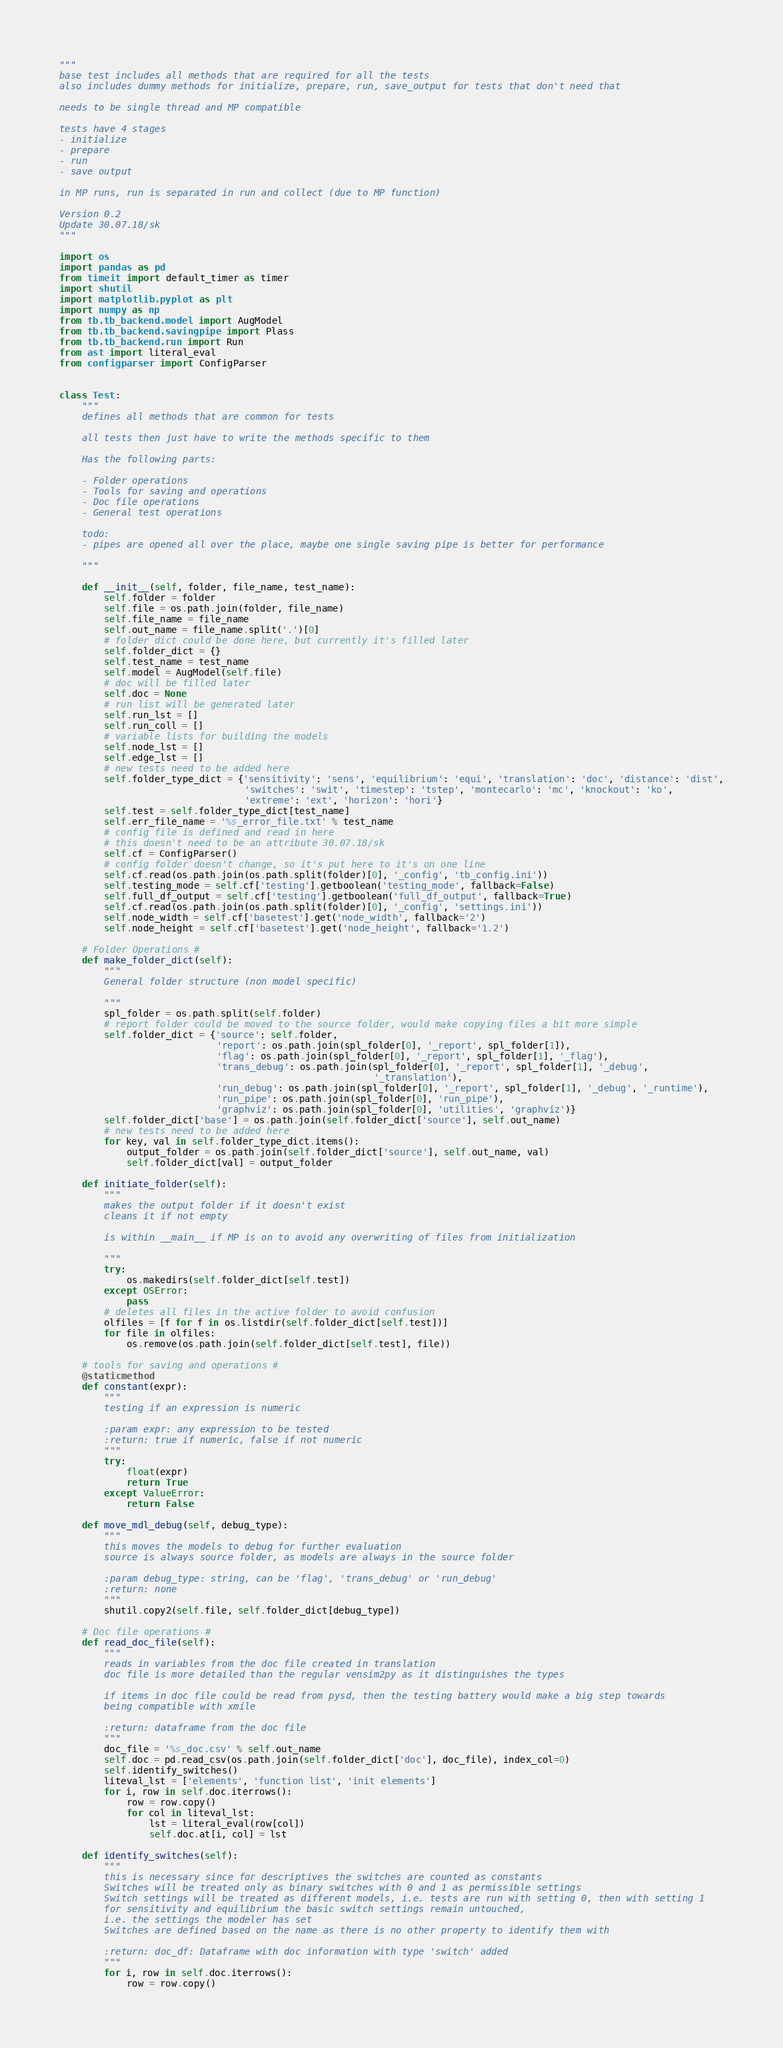<code> <loc_0><loc_0><loc_500><loc_500><_Python_>"""
base test includes all methods that are required for all the tests
also includes dummy methods for initialize, prepare, run, save_output for tests that don't need that

needs to be single thread and MP compatible

tests have 4 stages
- initialize
- prepare
- run
- save output

in MP runs, run is separated in run and collect (due to MP function)

Version 0.2
Update 30.07.18/sk
"""

import os
import pandas as pd
from timeit import default_timer as timer
import shutil
import matplotlib.pyplot as plt
import numpy as np
from tb.tb_backend.model import AugModel
from tb.tb_backend.savingpipe import Plass
from tb.tb_backend.run import Run
from ast import literal_eval
from configparser import ConfigParser


class Test:
    """
    defines all methods that are common for tests

    all tests then just have to write the methods specific to them

    Has the following parts:

    - Folder operations
    - Tools for saving and operations
    - Doc file operations
    - General test operations

    todo:
    - pipes are opened all over the place, maybe one single saving pipe is better for performance

    """

    def __init__(self, folder, file_name, test_name):
        self.folder = folder
        self.file = os.path.join(folder, file_name)
        self.file_name = file_name
        self.out_name = file_name.split('.')[0]
        # folder dict could be done here, but currently it's filled later
        self.folder_dict = {}
        self.test_name = test_name
        self.model = AugModel(self.file)
        # doc will be filled later
        self.doc = None
        # run list will be generated later
        self.run_lst = []
        self.run_coll = []
        # variable lists for building the models
        self.node_lst = []
        self.edge_lst = []
        # new tests need to be added here
        self.folder_type_dict = {'sensitivity': 'sens', 'equilibrium': 'equi', 'translation': 'doc', 'distance': 'dist',
                                 'switches': 'swit', 'timestep': 'tstep', 'montecarlo': 'mc', 'knockout': 'ko',
                                 'extreme': 'ext', 'horizon': 'hori'}
        self.test = self.folder_type_dict[test_name]
        self.err_file_name = '%s_error_file.txt' % test_name
        # config file is defined and read in here
        # this doesn't need to be an attribute 30.07.18/sk
        self.cf = ConfigParser()
        # config folder doesn't change, so it's put here to it's on one line
        self.cf.read(os.path.join(os.path.split(folder)[0], '_config', 'tb_config.ini'))
        self.testing_mode = self.cf['testing'].getboolean('testing_mode', fallback=False)
        self.full_df_output = self.cf['testing'].getboolean('full_df_output', fallback=True)
        self.cf.read(os.path.join(os.path.split(folder)[0], '_config', 'settings.ini'))
        self.node_width = self.cf['basetest'].get('node_width', fallback='2')
        self.node_height = self.cf['basetest'].get('node_height', fallback='1.2')

    # Folder Operations #
    def make_folder_dict(self):
        """
        General folder structure (non model specific)

        """
        spl_folder = os.path.split(self.folder)
        # report folder could be moved to the source folder, would make copying files a bit more simple
        self.folder_dict = {'source': self.folder,
                            'report': os.path.join(spl_folder[0], '_report', spl_folder[1]),
                            'flag': os.path.join(spl_folder[0], '_report', spl_folder[1], '_flag'),
                            'trans_debug': os.path.join(spl_folder[0], '_report', spl_folder[1], '_debug',
                                                        '_translation'),
                            'run_debug': os.path.join(spl_folder[0], '_report', spl_folder[1], '_debug', '_runtime'),
                            'run_pipe': os.path.join(spl_folder[0], 'run_pipe'),
                            'graphviz': os.path.join(spl_folder[0], 'utilities', 'graphviz')}
        self.folder_dict['base'] = os.path.join(self.folder_dict['source'], self.out_name)
        # new tests need to be added here
        for key, val in self.folder_type_dict.items():
            output_folder = os.path.join(self.folder_dict['source'], self.out_name, val)
            self.folder_dict[val] = output_folder

    def initiate_folder(self):
        """
        makes the output folder if it doesn't exist
        cleans it if not empty

        is within __main__ if MP is on to avoid any overwriting of files from initialization

        """
        try:
            os.makedirs(self.folder_dict[self.test])
        except OSError:
            pass
        # deletes all files in the active folder to avoid confusion
        olfiles = [f for f in os.listdir(self.folder_dict[self.test])]
        for file in olfiles:
            os.remove(os.path.join(self.folder_dict[self.test], file))

    # tools for saving and operations #
    @staticmethod
    def constant(expr):
        """
        testing if an expression is numeric

        :param expr: any expression to be tested
        :return: true if numeric, false if not numeric
        """
        try:
            float(expr)
            return True
        except ValueError:
            return False

    def move_mdl_debug(self, debug_type):
        """
        this moves the models to debug for further evaluation
        source is always source folder, as models are always in the source folder

        :param debug_type: string, can be 'flag', 'trans_debug' or 'run_debug'
        :return: none
        """
        shutil.copy2(self.file, self.folder_dict[debug_type])

    # Doc file operations #
    def read_doc_file(self):
        """
        reads in variables from the doc file created in translation
        doc file is more detailed than the regular vensim2py as it distinguishes the types

        if items in doc file could be read from pysd, then the testing battery would make a big step towards
        being compatible with xmile

        :return: dataframe from the doc file
        """
        doc_file = '%s_doc.csv' % self.out_name
        self.doc = pd.read_csv(os.path.join(self.folder_dict['doc'], doc_file), index_col=0)
        self.identify_switches()
        liteval_lst = ['elements', 'function list', 'init elements']
        for i, row in self.doc.iterrows():
            row = row.copy()
            for col in liteval_lst:
                lst = literal_eval(row[col])
                self.doc.at[i, col] = lst

    def identify_switches(self):
        """
        this is necessary since for descriptives the switches are counted as constants
        Switches will be treated only as binary switches with 0 and 1 as permissible settings
        Switch settings will be treated as different models, i.e. tests are run with setting 0, then with setting 1
        for sensitivity and equilibrium the basic switch settings remain untouched,
        i.e. the settings the modeler has set
        Switches are defined based on the name as there is no other property to identify them with

        :return: doc_df: Dataframe with doc information with type 'switch' added
        """
        for i, row in self.doc.iterrows():
            row = row.copy()</code> 